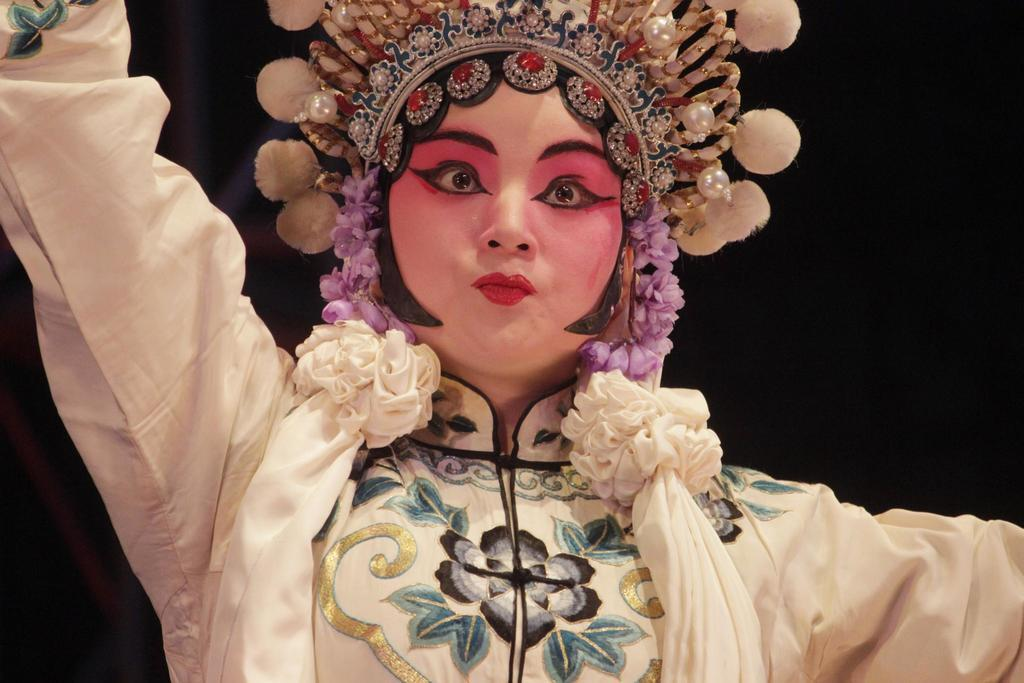What is the main subject of the image? There is a person in the image. What type of laborer is attacking the person in the image? There is no laborer or attack present in the image; it only features a person. What answer is the person providing in the image? There is no indication in the image that the person is providing an answer to a question or statement. 